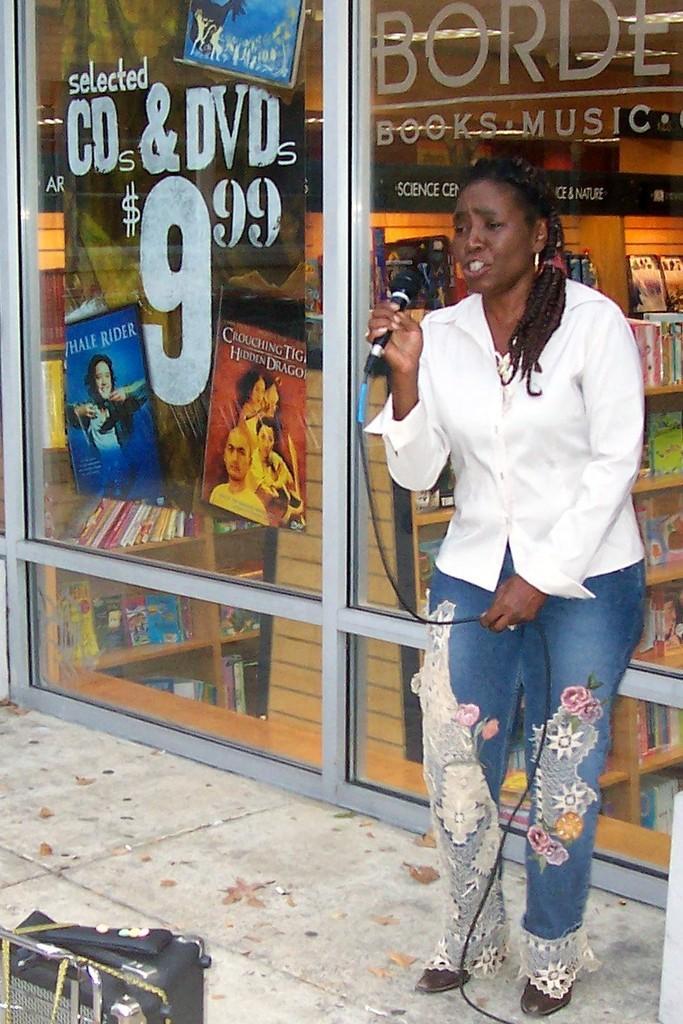Describe this image in one or two sentences. On the right side of the image, we can see a woman is holding a microphone and wire. She is standing on the path. At the bottom of the image, we can see an object. Background we can see the glass objects and posters. Through the glass we can see inside view of a store. 